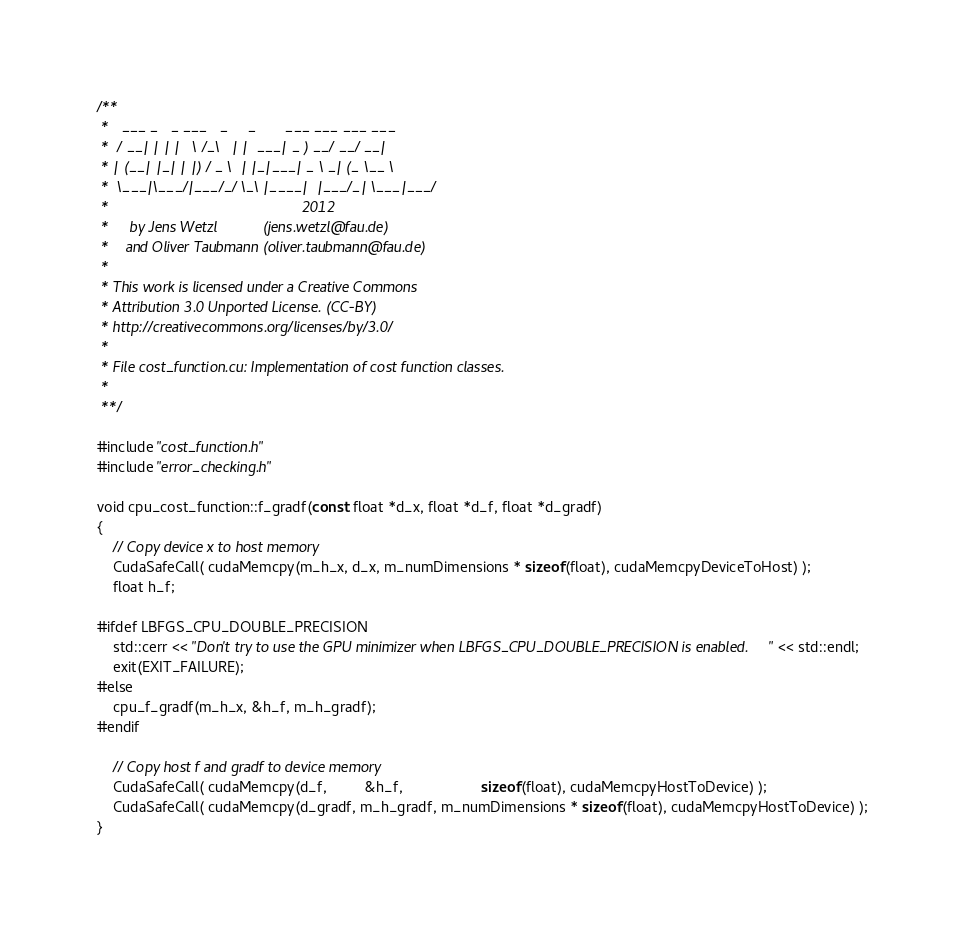<code> <loc_0><loc_0><loc_500><loc_500><_Cuda_>/**
 *   ___ _   _ ___   _     _       ___ ___ ___ ___
 *  / __| | | |   \ /_\   | |  ___| _ ) __/ __/ __|
 * | (__| |_| | |) / _ \  | |_|___| _ \ _| (_ \__ \
 *  \___|\___/|___/_/ \_\ |____|  |___/_| \___|___/
 *                                               2012
 *     by Jens Wetzl           (jens.wetzl@fau.de)
 *    and Oliver Taubmann (oliver.taubmann@fau.de)
 *
 * This work is licensed under a Creative Commons
 * Attribution 3.0 Unported License. (CC-BY)
 * http://creativecommons.org/licenses/by/3.0/
 *
 * File cost_function.cu: Implementation of cost function classes.
 *
 **/

#include "cost_function.h"
#include "error_checking.h"

void cpu_cost_function::f_gradf(const float *d_x, float *d_f, float *d_gradf)
{
	// Copy device x to host memory
	CudaSafeCall( cudaMemcpy(m_h_x, d_x, m_numDimensions * sizeof(float), cudaMemcpyDeviceToHost) );
	float h_f;

#ifdef LBFGS_CPU_DOUBLE_PRECISION
	std::cerr << "Don't try to use the GPU minimizer when LBFGS_CPU_DOUBLE_PRECISION is enabled." << std::endl;
	exit(EXIT_FAILURE);
#else
	cpu_f_gradf(m_h_x, &h_f, m_h_gradf);
#endif

	// Copy host f and gradf to device memory
	CudaSafeCall( cudaMemcpy(d_f,         &h_f,                   sizeof(float), cudaMemcpyHostToDevice) );
	CudaSafeCall( cudaMemcpy(d_gradf, m_h_gradf, m_numDimensions * sizeof(float), cudaMemcpyHostToDevice) );
}
</code> 